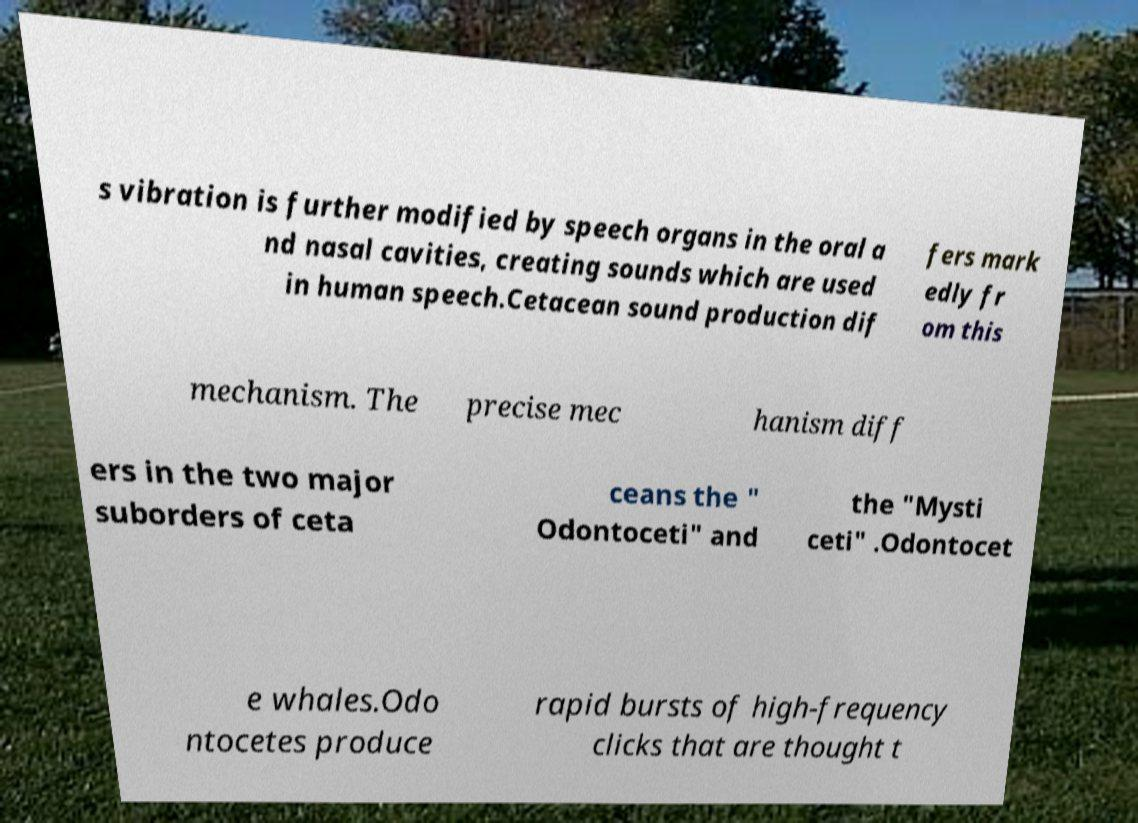Please read and relay the text visible in this image. What does it say? s vibration is further modified by speech organs in the oral a nd nasal cavities, creating sounds which are used in human speech.Cetacean sound production dif fers mark edly fr om this mechanism. The precise mec hanism diff ers in the two major suborders of ceta ceans the " Odontoceti" and the "Mysti ceti" .Odontocet e whales.Odo ntocetes produce rapid bursts of high-frequency clicks that are thought t 